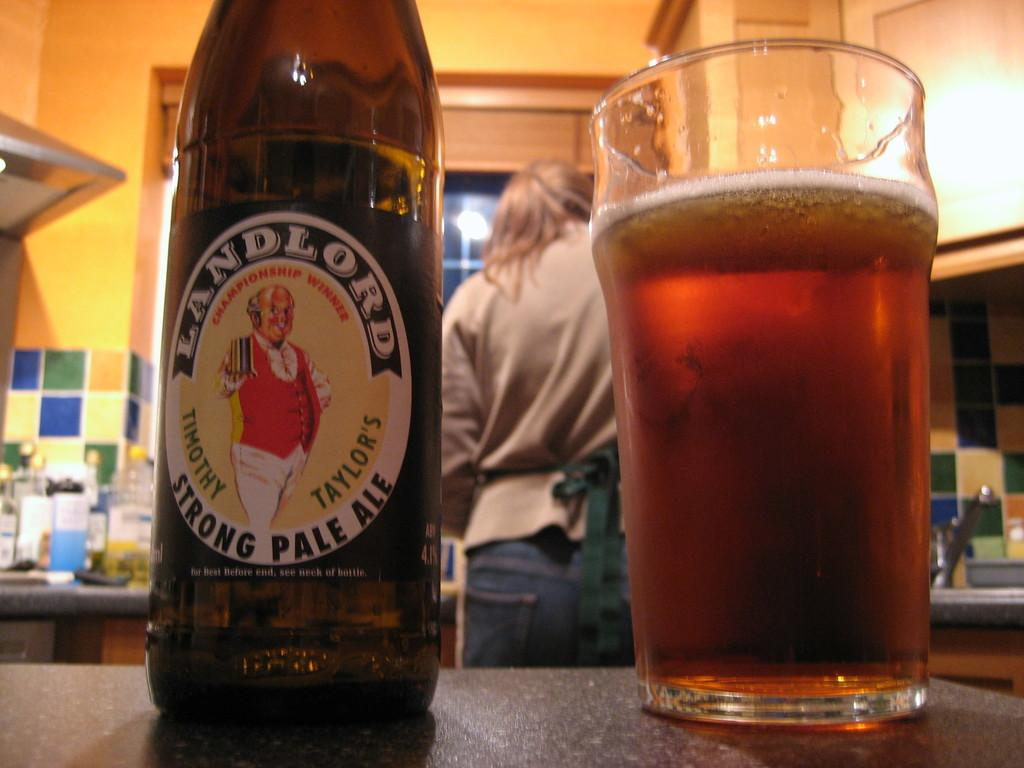<image>
Write a terse but informative summary of the picture. a bottle of landlord strong pale ale standing next to a glass of it 